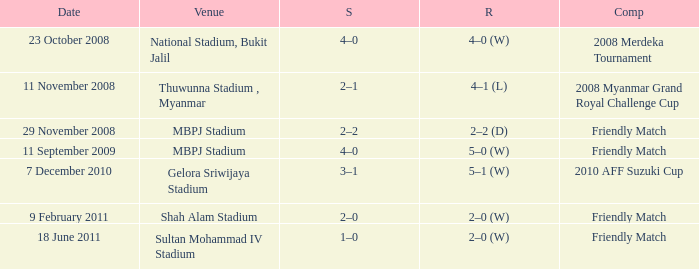What is the Result of the Competition at MBPJ Stadium with a Score of 4–0? 5–0 (W). 